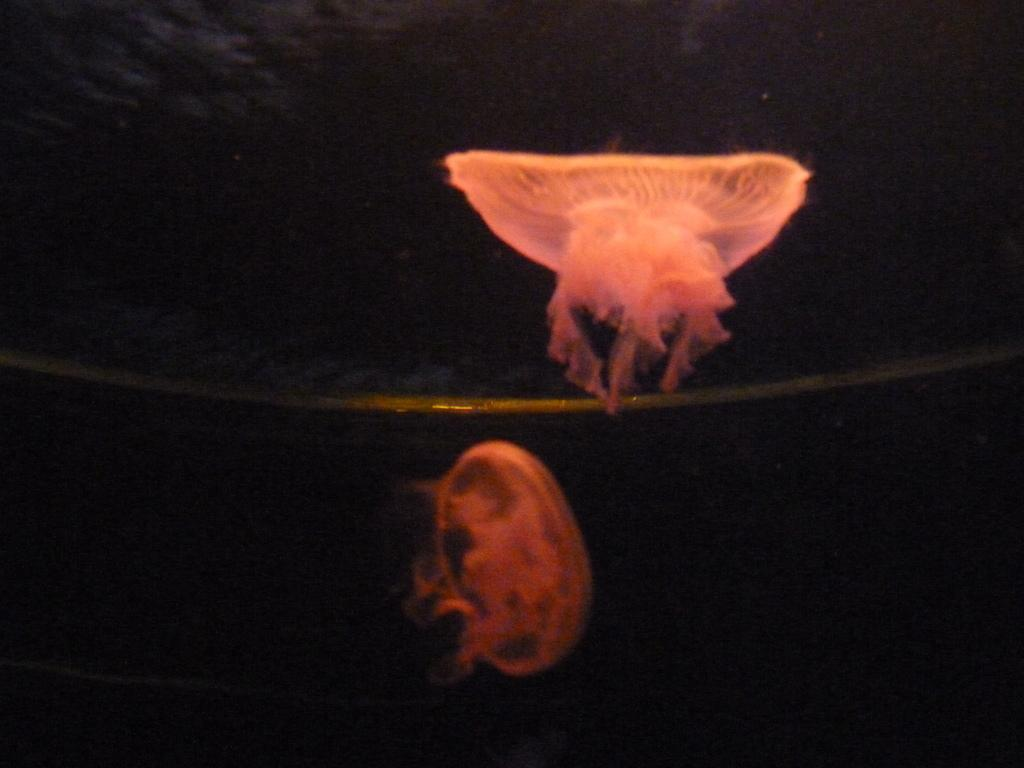What creatures are present in the image? There are two pink jellyfish in the image. What color is the background of the image? The background of the image is black. Where is the rabbit hiding in the image? There is no rabbit present in the image; it only features two pink jellyfish. What type of bone can be seen in the image? There are no bones present in the image; it only features two pink jellyfish against a black background. 